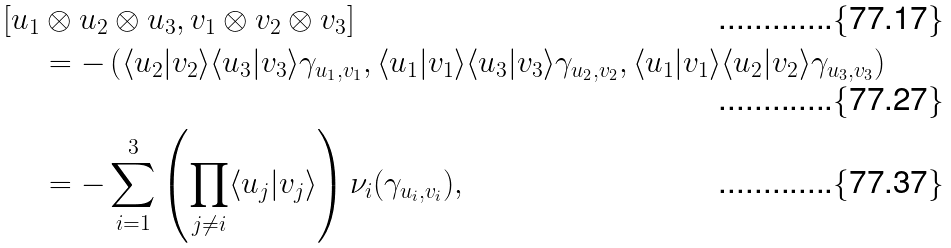Convert formula to latex. <formula><loc_0><loc_0><loc_500><loc_500>[ u _ { 1 } & \otimes u _ { 2 } \otimes u _ { 3 } , v _ { 1 } \otimes v _ { 2 } \otimes v _ { 3 } ] \\ & = - \left ( \langle u _ { 2 } | v _ { 2 } \rangle \langle u _ { 3 } | v _ { 3 } \rangle \gamma _ { u _ { 1 } , v _ { 1 } } , \langle u _ { 1 } | v _ { 1 } \rangle \langle u _ { 3 } | v _ { 3 } \rangle \gamma _ { u _ { 2 } , v _ { 2 } } , \langle u _ { 1 } | v _ { 1 } \rangle \langle u _ { 2 } | v _ { 2 } \rangle \gamma _ { u _ { 3 } , v _ { 3 } } \right ) \\ & = - \sum _ { i = 1 } ^ { 3 } \left ( \prod _ { j \ne i } \langle u _ { j } | v _ { j } \rangle \right ) \nu _ { i } ( \gamma _ { u _ { i } , v _ { i } } ) ,</formula> 